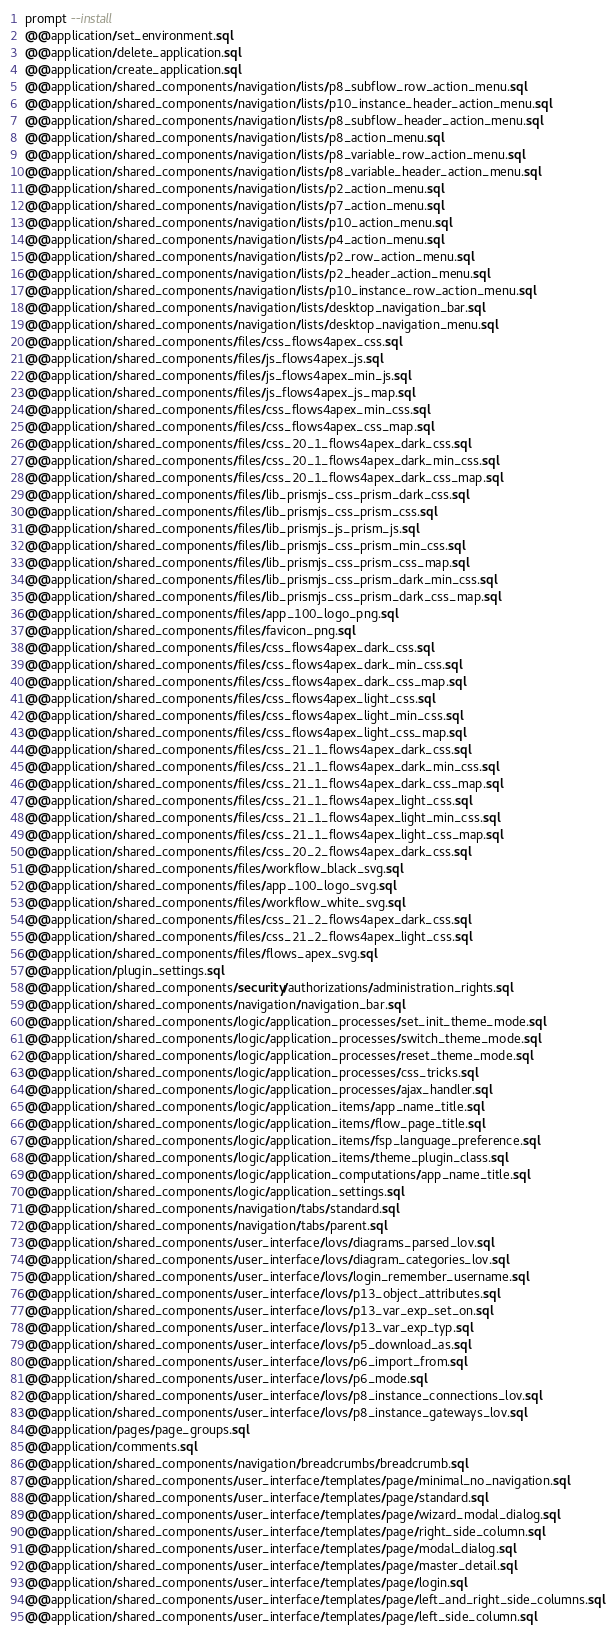Convert code to text. <code><loc_0><loc_0><loc_500><loc_500><_SQL_>prompt --install
@@application/set_environment.sql
@@application/delete_application.sql
@@application/create_application.sql
@@application/shared_components/navigation/lists/p8_subflow_row_action_menu.sql
@@application/shared_components/navigation/lists/p10_instance_header_action_menu.sql
@@application/shared_components/navigation/lists/p8_subflow_header_action_menu.sql
@@application/shared_components/navigation/lists/p8_action_menu.sql
@@application/shared_components/navigation/lists/p8_variable_row_action_menu.sql
@@application/shared_components/navigation/lists/p8_variable_header_action_menu.sql
@@application/shared_components/navigation/lists/p2_action_menu.sql
@@application/shared_components/navigation/lists/p7_action_menu.sql
@@application/shared_components/navigation/lists/p10_action_menu.sql
@@application/shared_components/navigation/lists/p4_action_menu.sql
@@application/shared_components/navigation/lists/p2_row_action_menu.sql
@@application/shared_components/navigation/lists/p2_header_action_menu.sql
@@application/shared_components/navigation/lists/p10_instance_row_action_menu.sql
@@application/shared_components/navigation/lists/desktop_navigation_bar.sql
@@application/shared_components/navigation/lists/desktop_navigation_menu.sql
@@application/shared_components/files/css_flows4apex_css.sql
@@application/shared_components/files/js_flows4apex_js.sql
@@application/shared_components/files/js_flows4apex_min_js.sql
@@application/shared_components/files/js_flows4apex_js_map.sql
@@application/shared_components/files/css_flows4apex_min_css.sql
@@application/shared_components/files/css_flows4apex_css_map.sql
@@application/shared_components/files/css_20_1_flows4apex_dark_css.sql
@@application/shared_components/files/css_20_1_flows4apex_dark_min_css.sql
@@application/shared_components/files/css_20_1_flows4apex_dark_css_map.sql
@@application/shared_components/files/lib_prismjs_css_prism_dark_css.sql
@@application/shared_components/files/lib_prismjs_css_prism_css.sql
@@application/shared_components/files/lib_prismjs_js_prism_js.sql
@@application/shared_components/files/lib_prismjs_css_prism_min_css.sql
@@application/shared_components/files/lib_prismjs_css_prism_css_map.sql
@@application/shared_components/files/lib_prismjs_css_prism_dark_min_css.sql
@@application/shared_components/files/lib_prismjs_css_prism_dark_css_map.sql
@@application/shared_components/files/app_100_logo_png.sql
@@application/shared_components/files/favicon_png.sql
@@application/shared_components/files/css_flows4apex_dark_css.sql
@@application/shared_components/files/css_flows4apex_dark_min_css.sql
@@application/shared_components/files/css_flows4apex_dark_css_map.sql
@@application/shared_components/files/css_flows4apex_light_css.sql
@@application/shared_components/files/css_flows4apex_light_min_css.sql
@@application/shared_components/files/css_flows4apex_light_css_map.sql
@@application/shared_components/files/css_21_1_flows4apex_dark_css.sql
@@application/shared_components/files/css_21_1_flows4apex_dark_min_css.sql
@@application/shared_components/files/css_21_1_flows4apex_dark_css_map.sql
@@application/shared_components/files/css_21_1_flows4apex_light_css.sql
@@application/shared_components/files/css_21_1_flows4apex_light_min_css.sql
@@application/shared_components/files/css_21_1_flows4apex_light_css_map.sql
@@application/shared_components/files/css_20_2_flows4apex_dark_css.sql
@@application/shared_components/files/workflow_black_svg.sql
@@application/shared_components/files/app_100_logo_svg.sql
@@application/shared_components/files/workflow_white_svg.sql
@@application/shared_components/files/css_21_2_flows4apex_dark_css.sql
@@application/shared_components/files/css_21_2_flows4apex_light_css.sql
@@application/shared_components/files/flows_apex_svg.sql
@@application/plugin_settings.sql
@@application/shared_components/security/authorizations/administration_rights.sql
@@application/shared_components/navigation/navigation_bar.sql
@@application/shared_components/logic/application_processes/set_init_theme_mode.sql
@@application/shared_components/logic/application_processes/switch_theme_mode.sql
@@application/shared_components/logic/application_processes/reset_theme_mode.sql
@@application/shared_components/logic/application_processes/css_tricks.sql
@@application/shared_components/logic/application_processes/ajax_handler.sql
@@application/shared_components/logic/application_items/app_name_title.sql
@@application/shared_components/logic/application_items/flow_page_title.sql
@@application/shared_components/logic/application_items/fsp_language_preference.sql
@@application/shared_components/logic/application_items/theme_plugin_class.sql
@@application/shared_components/logic/application_computations/app_name_title.sql
@@application/shared_components/logic/application_settings.sql
@@application/shared_components/navigation/tabs/standard.sql
@@application/shared_components/navigation/tabs/parent.sql
@@application/shared_components/user_interface/lovs/diagrams_parsed_lov.sql
@@application/shared_components/user_interface/lovs/diagram_categories_lov.sql
@@application/shared_components/user_interface/lovs/login_remember_username.sql
@@application/shared_components/user_interface/lovs/p13_object_attributes.sql
@@application/shared_components/user_interface/lovs/p13_var_exp_set_on.sql
@@application/shared_components/user_interface/lovs/p13_var_exp_typ.sql
@@application/shared_components/user_interface/lovs/p5_download_as.sql
@@application/shared_components/user_interface/lovs/p6_import_from.sql
@@application/shared_components/user_interface/lovs/p6_mode.sql
@@application/shared_components/user_interface/lovs/p8_instance_connections_lov.sql
@@application/shared_components/user_interface/lovs/p8_instance_gateways_lov.sql
@@application/pages/page_groups.sql
@@application/comments.sql
@@application/shared_components/navigation/breadcrumbs/breadcrumb.sql
@@application/shared_components/user_interface/templates/page/minimal_no_navigation.sql
@@application/shared_components/user_interface/templates/page/standard.sql
@@application/shared_components/user_interface/templates/page/wizard_modal_dialog.sql
@@application/shared_components/user_interface/templates/page/right_side_column.sql
@@application/shared_components/user_interface/templates/page/modal_dialog.sql
@@application/shared_components/user_interface/templates/page/master_detail.sql
@@application/shared_components/user_interface/templates/page/login.sql
@@application/shared_components/user_interface/templates/page/left_and_right_side_columns.sql
@@application/shared_components/user_interface/templates/page/left_side_column.sql</code> 